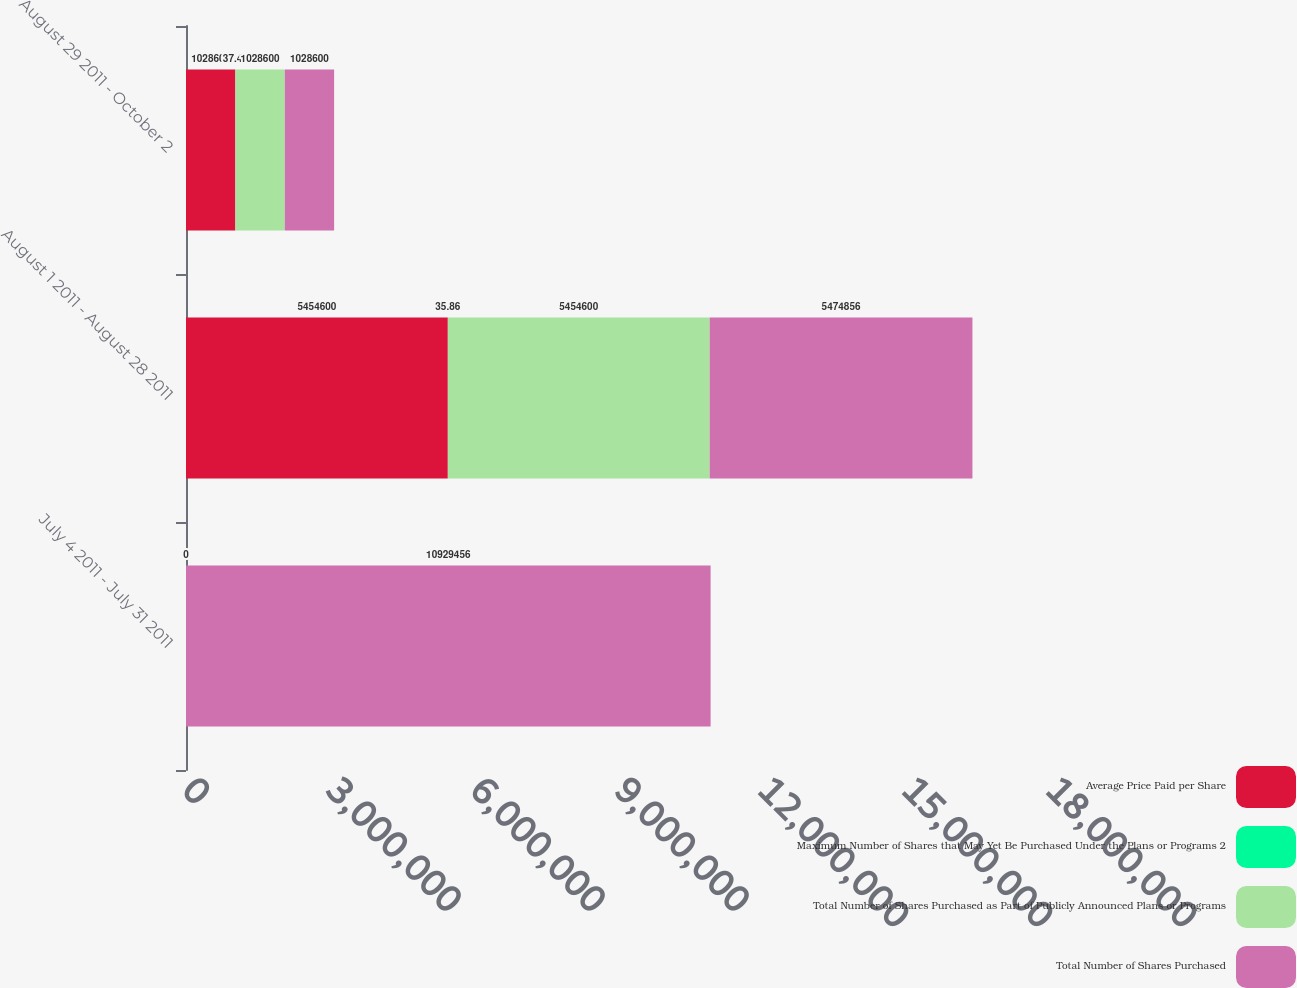Convert chart to OTSL. <chart><loc_0><loc_0><loc_500><loc_500><stacked_bar_chart><ecel><fcel>July 4 2011 - July 31 2011<fcel>August 1 2011 - August 28 2011<fcel>August 29 2011 - October 2<nl><fcel>Average Price Paid per Share<fcel>0<fcel>5.4546e+06<fcel>1.0286e+06<nl><fcel>Maximum Number of Shares that May Yet Be Purchased Under the Plans or Programs 2<fcel>0<fcel>35.86<fcel>37.41<nl><fcel>Total Number of Shares Purchased as Part of Publicly Announced Plans or Programs<fcel>0<fcel>5.4546e+06<fcel>1.0286e+06<nl><fcel>Total Number of Shares Purchased<fcel>1.09295e+07<fcel>5.47486e+06<fcel>1.0286e+06<nl></chart> 